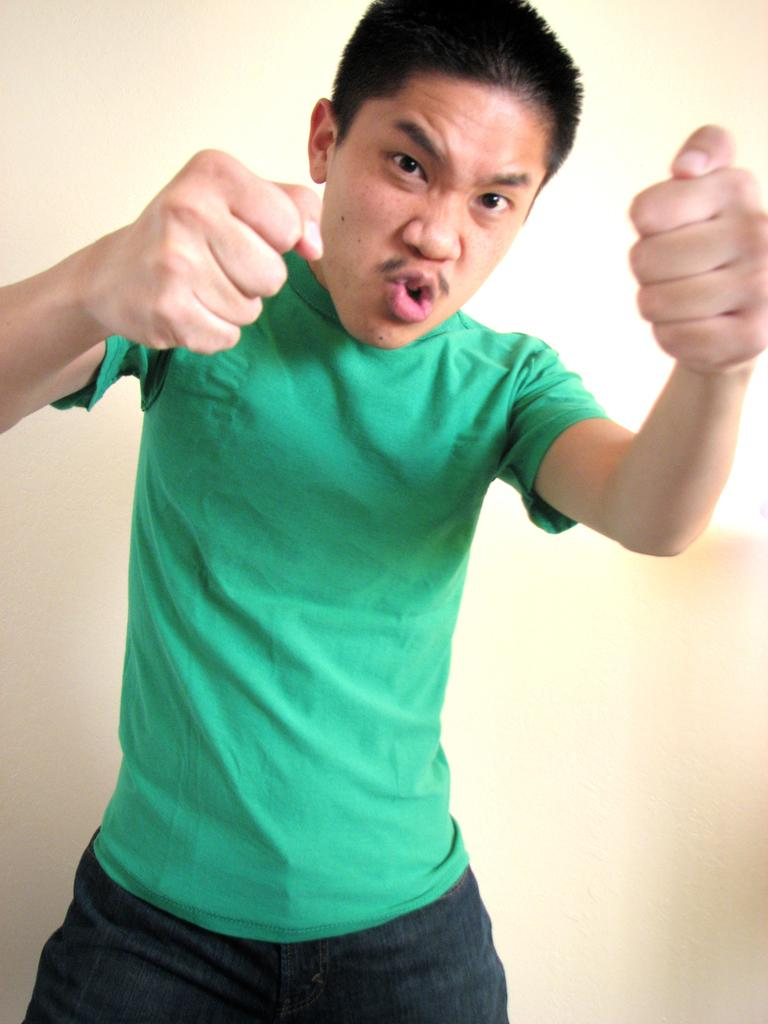What is present in the image? There is a person in the image. What is the person wearing? The person is wearing a green t-shirt. What is the person's posture in the image? The person is standing. What type of patch can be seen on the person's coat in the image? There is no coat present in the image, and therefore no patch can be seen. 